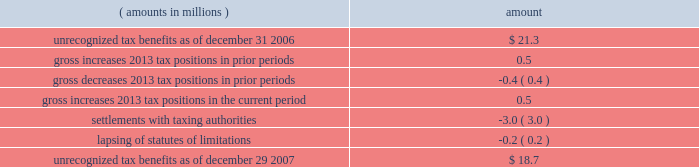Notes to consolidated financial statements ( continued ) | 72 snap-on incorporated following is a reconciliation of the beginning and ending amount of unrecognized tax benefits : ( amounts in millions ) amount .
Of the $ 18.7 million of unrecognized tax benefits at the end of 2007 , approximately $ 16.2 million would impact the effective income tax rate if recognized .
Interest and penalties related to unrecognized tax benefits are recorded in income tax expense .
During the years ended december 29 , 2007 , december 30 , 2006 , and december 31 , 2005 , the company recognized approximately $ 1.2 million , $ 0.5 million and ( $ 0.5 ) million in net interest expense ( benefit ) , respectively .
The company has provided for approximately $ 3.4 million , $ 2.2 million , and $ 1.7 million of accrued interest related to unrecognized tax benefits at the end of fiscal year 2007 , 2006 and 2005 , respectively .
During the next 12 months , the company does not anticipate any significant changes to the total amount of unrecognized tax benefits , other than the accrual of additional interest expense in an amount similar to the prior year 2019s expense .
With few exceptions , snap-on is no longer subject to u.s .
Federal and state/local income tax examinations by tax authorities for years prior to 2003 , and snap-on is no longer subject to non-u.s .
Income tax examinations by tax authorities for years prior to 2001 .
The undistributed earnings of all non-u.s .
Subsidiaries totaled $ 338.5 million , $ 247.4 million and $ 173.6 million at the end of fiscal 2007 , 2006 and 2005 , respectively .
Snap-on has not provided any deferred taxes on these undistributed earnings as it considers the undistributed earnings to be permanently invested .
Determination of the amount of unrecognized deferred income tax liability related to these earnings is not practicable .
The american jobs creation act of 2004 ( the 201cajca 201d ) created a one-time tax incentive for u.s .
Corporations to repatriate accumulated foreign earnings by providing a tax deduction of 85% ( 85 % ) of qualifying dividends received from foreign affiliates .
Under the provisions of the ajca , snap-on repatriated approximately $ 93 million of qualifying dividends in 2005 that resulted in additional income tax expense of $ 3.3 million for the year .
Note 9 : short-term and long-term debt notes payable and long-term debt as of december 29 , 2007 , was $ 517.9 million ; no commercial paper was outstanding at december 29 , 2007 .
As of december 30 , 2006 , notes payable and long-term debt was $ 549.2 million , including $ 314.9 million of commercial paper .
Snap-on presented $ 300 million of the december 30 , 2006 , outstanding commercial paper as 201clong-term debt 201d on the accompanying december 30 , 2006 , consolidated balance sheet .
On january 12 , 2007 , snap-on sold $ 300 million of unsecured notes consisting of $ 150 million of floating rate notes that mature on january 12 , 2010 , and $ 150 million of fixed rate notes that mature on january 15 , 2017 .
Interest on the floating rate notes accrues at a rate equal to the three-month london interbank offer rate plus 0.13% ( 0.13 % ) per year and is payable quarterly .
Interest on the fixed rate notes accrues at a rate of 5.50% ( 5.50 % ) per year and is payable semi-annually .
Snap-on used the proceeds from the sale of the notes , net of $ 1.5 million of transaction costs , to repay commercial paper obligations issued to finance the acquisition of business solutions .
On january 12 , 2007 , the company also terminated a $ 250 million bridge credit agreement that snap-on established prior to its acquisition of business solutions. .
In 2007 what was the change in the unrecognized tax benefits in millions? 
Computations: ((18.7 - 21.3) / 21.3)
Answer: -0.12207. 